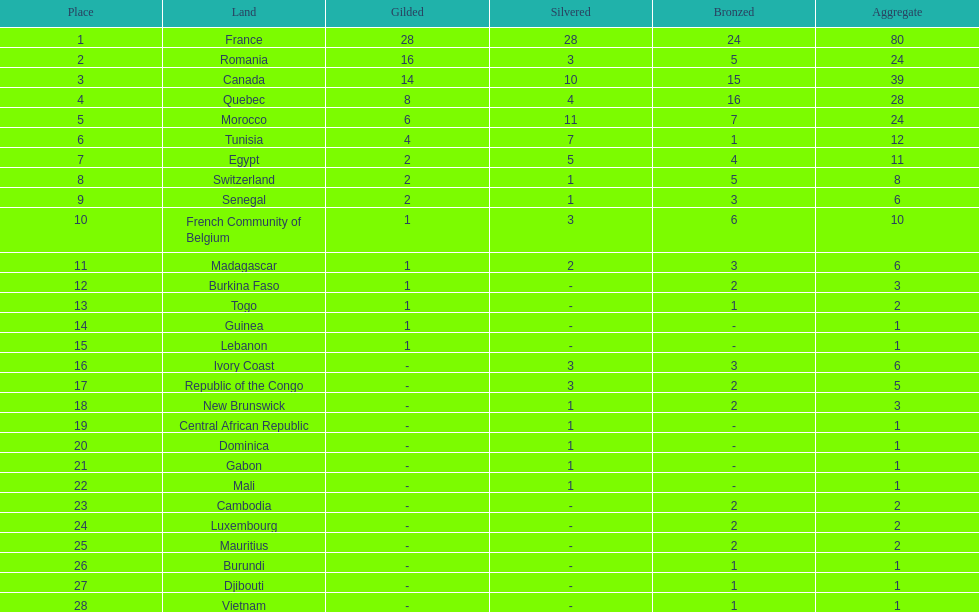What was the total medal count of switzerland? 8. 